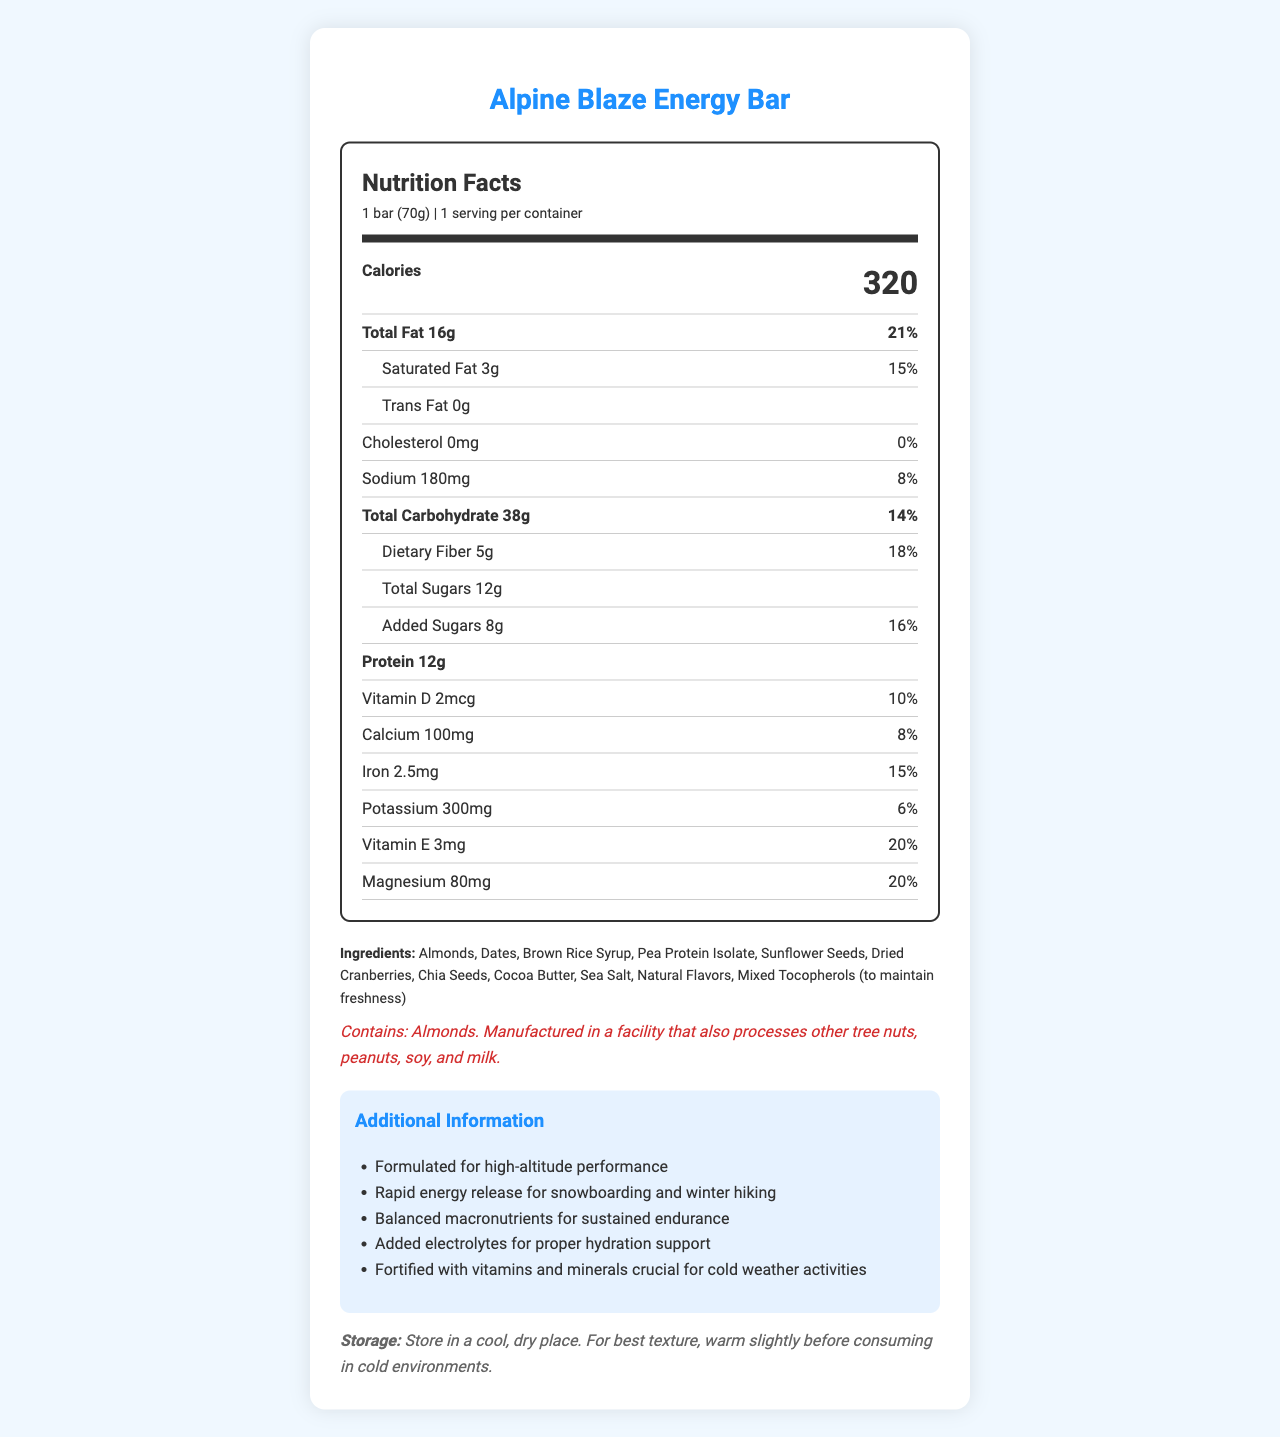what is the serving size of the Alpine Blaze Energy Bar? The serving size is explicitly mentioned under the product name and nutrition facts section.
Answer: 1 bar (70g) how many calories are in one serving of the Alpine Blaze Energy Bar? The calories content is shown in a prominent, bold font within the nutrition facts section.
Answer: 320 what percentage of the daily value of total fat is in one bar? The daily value percentage for total fat is listed next to the amount of total fat.
Answer: 21% name two ingredients in the Alpine Blaze Energy Bar. The ingredients list is provided towards the bottom of the document.
Answer: Almonds, Dates what is the total amount of protein in one serving? The protein content is given in the nutrition facts section under the bold nutrient row.
Answer: 12g which of the following is not an ingredient in the Alpine Blaze Energy Bar? A. Almonds B. Peanuts C. Chia Seeds D. Dates Peanuts are not listed in the ingredients, while Almonds, Chia Seeds, and Dates are.
Answer: B what is the daily value percentage for dietary fiber in the Alpine Blaze Energy Bar? The daily value percentage for dietary fiber is mentioned next to its amount in grams.
Answer: 18% which vitamin is included in the highest amount based on the daily value percentage? A. Vitamin D B. Calcium C. Magnesium D. Vitamin E Vitamin E is included at 20% of daily value, which is the highest among the options.
Answer: D is the Alpine Blaze Energy Bar suitable for someone with a tree nut allergy? The allergen information indicates that the product contains almonds and is manufactured in a facility that processes other tree nuts.
Answer: No describe the main purpose and nutrition goals of the Alpine Blaze Energy Bar. The document highlights the formulation, energy release, balanced macronutrients, electrolytes for hydration, and fortification with essential vitamins and minerals as key features of the product.
Answer: The Alpine Blaze Energy Bar is specifically formulated for winter outdoor enthusiasts offering high-altitude performance with a balanced blend of macronutrients for rapid energy release, sustained endurance, added electrolytes for hydration, and fortified with vitamins and minerals crucial for cold weather activities. what is the purpose of the mixed tocopherols in the ingredients? Mixed tocopherols are listed towards the end of the ingredients with a note that they are used to maintain freshness.
Answer: To maintain freshness how much potassium is in one serving of the Alpine Blaze Energy Bar? The potassium content is provided under the nutrition facts section, mentioning the amount in milligrams and daily value percentage.
Answer: 300mg can I determine the exact price of the Alpine Blaze Energy Bar from this document? The document does not provide any price information, so the price cannot be determined.
Answer: Not enough information what are the storage instructions for the Alpine Blaze Energy Bar? The storage instructions are provided at the end of the document.
Answer: Store in a cool, dry place. For best texture, warm slightly before consuming in cold environments. is there any cholesterol in the Alpine Blaze Energy Bar? The nutrition facts label specifies that the bar contains 0mg of cholesterol, which equates to 0% daily value.
Answer: No 